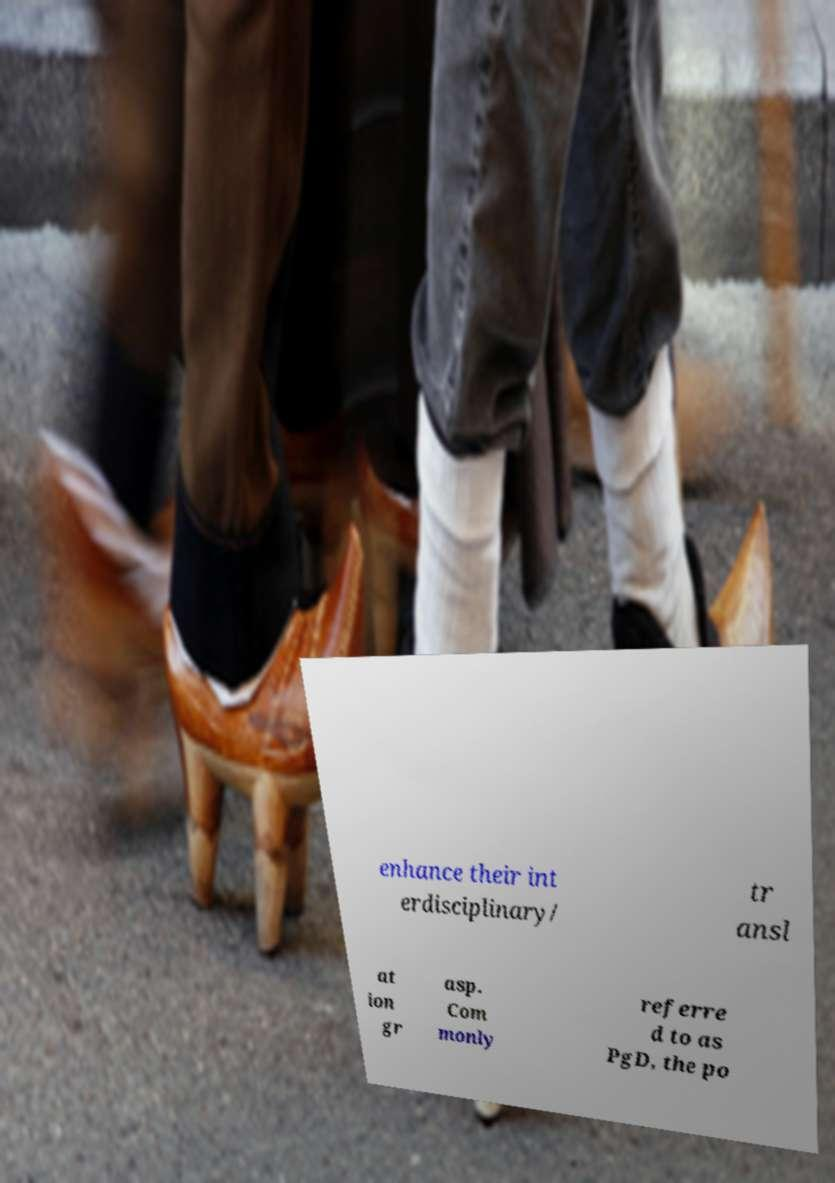Can you read and provide the text displayed in the image?This photo seems to have some interesting text. Can you extract and type it out for me? enhance their int erdisciplinary/ tr ansl at ion gr asp. Com monly referre d to as PgD, the po 